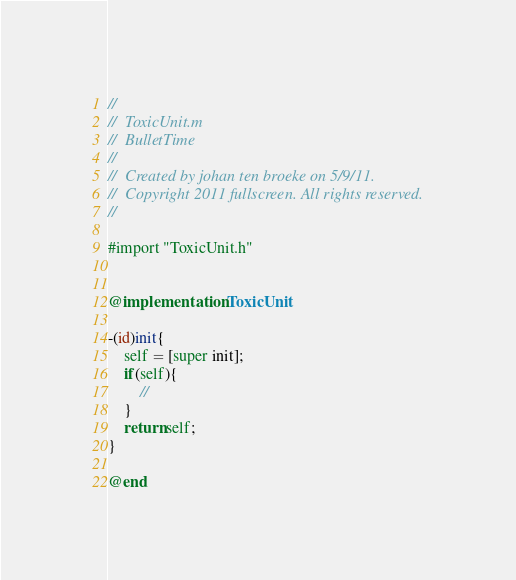Convert code to text. <code><loc_0><loc_0><loc_500><loc_500><_ObjectiveC_>//
//  ToxicUnit.m
//  BulletTime
//
//  Created by johan ten broeke on 5/9/11.
//  Copyright 2011 fullscreen. All rights reserved.
//

#import "ToxicUnit.h"


@implementation ToxicUnit

-(id)init{
    self = [super init];
    if(self){
        //
    }
    return self;
}

@end
</code> 